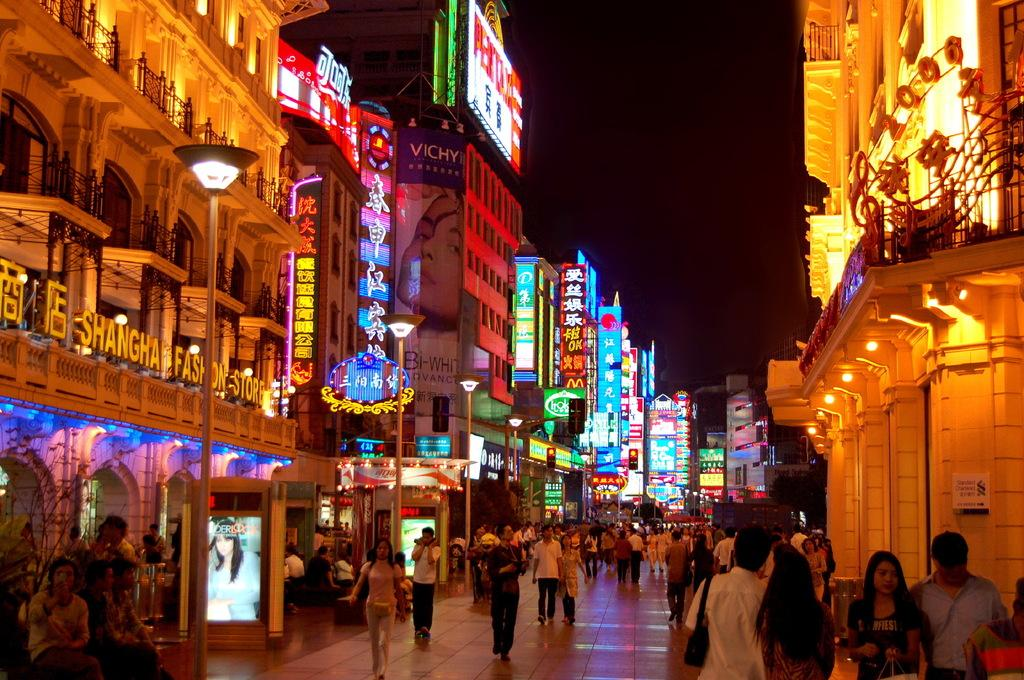<image>
Give a short and clear explanation of the subsequent image. Shanghai fashion store on a building with chinese symbols. 